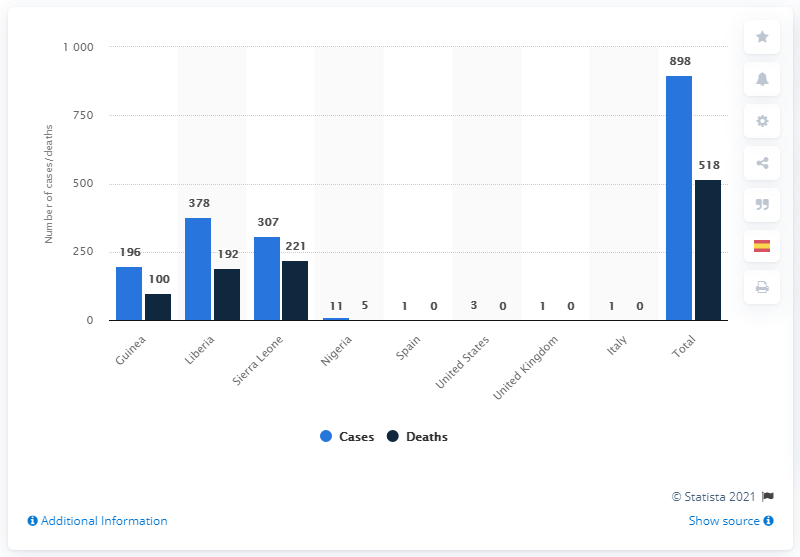Mention a couple of crucial points in this snapshot. As of November 4, 2015, there were 378 confirmed cases of Ebola in Liberia. According to records, the Ebola outbreak in Liberia resulted in 192 deaths. 